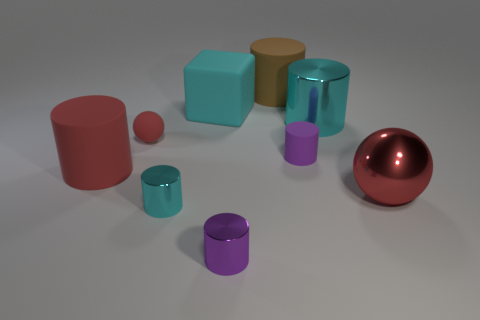Is there anything else that has the same shape as the cyan matte object?
Offer a very short reply. No. Is there a large cylinder that has the same color as the small rubber sphere?
Provide a short and direct response. Yes. Does the big red object that is behind the red metal object have the same material as the small cylinder that is in front of the tiny cyan object?
Your answer should be very brief. No. The rubber sphere has what color?
Provide a succinct answer. Red. What is the size of the red sphere that is right of the sphere that is behind the big cylinder that is left of the cyan cube?
Offer a very short reply. Large. What number of other things are there of the same size as the red rubber cylinder?
Give a very brief answer. 4. What number of purple cylinders have the same material as the brown cylinder?
Make the answer very short. 1. What shape is the small metallic thing in front of the small cyan object?
Keep it short and to the point. Cylinder. Do the red cylinder and the large cyan thing that is to the right of the purple rubber object have the same material?
Your answer should be very brief. No. Is there a red cylinder?
Your answer should be very brief. Yes. 